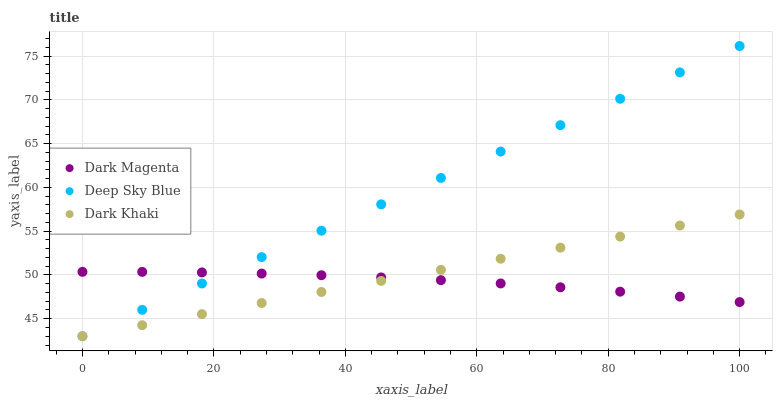Does Dark Magenta have the minimum area under the curve?
Answer yes or no. Yes. Does Deep Sky Blue have the maximum area under the curve?
Answer yes or no. Yes. Does Deep Sky Blue have the minimum area under the curve?
Answer yes or no. No. Does Dark Magenta have the maximum area under the curve?
Answer yes or no. No. Is Dark Khaki the smoothest?
Answer yes or no. Yes. Is Dark Magenta the roughest?
Answer yes or no. Yes. Is Deep Sky Blue the smoothest?
Answer yes or no. No. Is Deep Sky Blue the roughest?
Answer yes or no. No. Does Dark Khaki have the lowest value?
Answer yes or no. Yes. Does Dark Magenta have the lowest value?
Answer yes or no. No. Does Deep Sky Blue have the highest value?
Answer yes or no. Yes. Does Dark Magenta have the highest value?
Answer yes or no. No. Does Dark Magenta intersect Deep Sky Blue?
Answer yes or no. Yes. Is Dark Magenta less than Deep Sky Blue?
Answer yes or no. No. Is Dark Magenta greater than Deep Sky Blue?
Answer yes or no. No. 